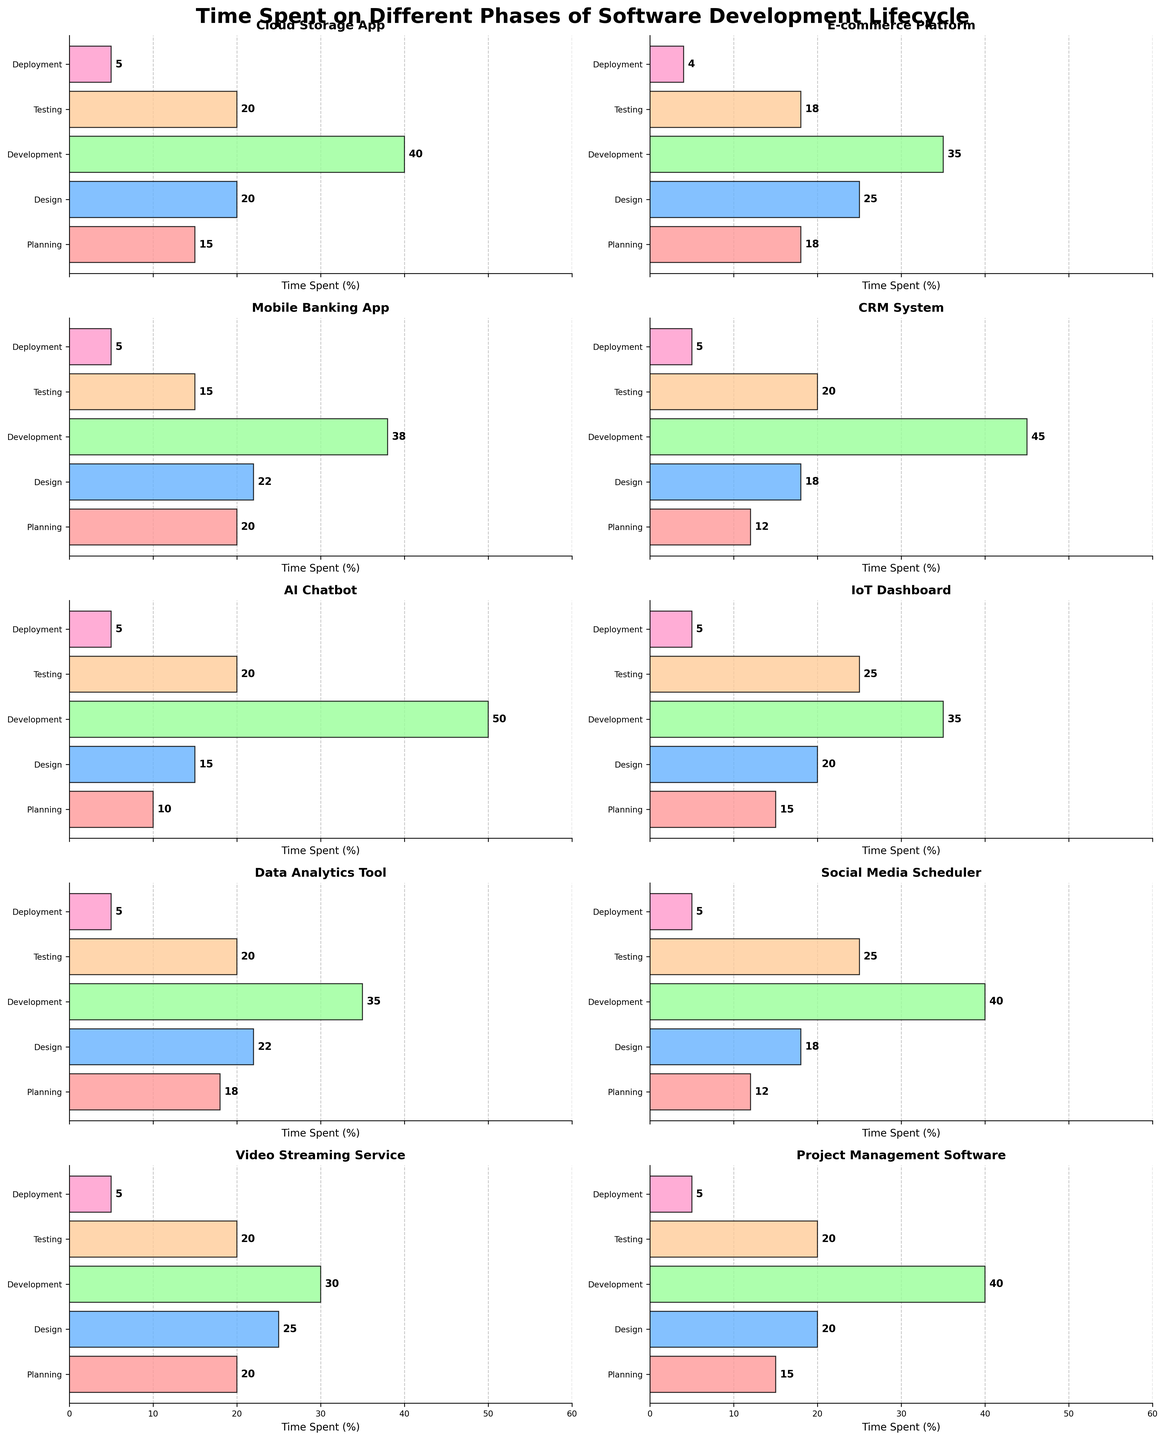What is the title of the figure? The title of the figure is written at the top of the plot in bold. By looking at the plot, we can identify the title.
Answer: Time Spent on Different Phases of Software Development Lifecycle Which project spent the least time in the Planning phase? By examining the horizontal bars for the Planning phase across all projects, we can identify the project with the shortest bar.
Answer: AI Chatbot How much total time is spent on Development and Testing for the E-commerce Platform? Summing the time spent on Development (35) and Testing (18) phases for the E-commerce Platform gives us the total time.
Answer: 53 Which phase had the highest time allocation in the IoT Dashboard project? By comparing the lengths of the bars for each phase in the IoT Dashboard subplot, we can identify the longest bar.
Answer: Testing Compare the time spent on the Deployment phase for the Cloud Storage App and the CRM System. Which one spent more time? By checking the horizontal bars for the Deployment phase in both projects, we see that both have the same length.
Answer: Equal What is the median time spent on the Design phase across all projects? First, list the time spent on Design across all projects: [20, 25, 22, 18, 15, 20, 22, 18, 25, 20]. Sort these values and find the middle value(s), calculating the median.
Answer: 20 For which project is the time spent on Development exactly 40? By inspecting the figure, look for the project where the horizontal bar for Development reads 40.
Answer: Cloud Storage App, Project Management Software, Social Media Scheduler Compare the total time spent on all phases for the Mobile Banking App and Video Streaming Service. Which one had a higher total? Sum the time spent on all phases for both the Mobile Banking App (20+22+38+15+5=100) and the Video Streaming Service (20+25+30+20+5=100). Both are equal.
Answer: Equal What is the average time spent on the Testing phase across all projects? Sum the time spent on Testing across all projects and divide by the number of projects: (20+18+15+20+20+25+20+25+20+20)/10 = 20.25
Answer: 20.25 Which project has the highest total time spent across all phases? Sum the times for all phases in each project and compare to find the highest. E-commerce Platform has (18+25+35+18+4)=100, CRM System has (12+18+45+20+5)=100, others are less than 100 except Social Media Scheduler which also adds up to 100. So multiple projects have the highest, but no single project exceeds 100.
Answer: E-commerce Platform, CRM System, Social Media Scheduler 